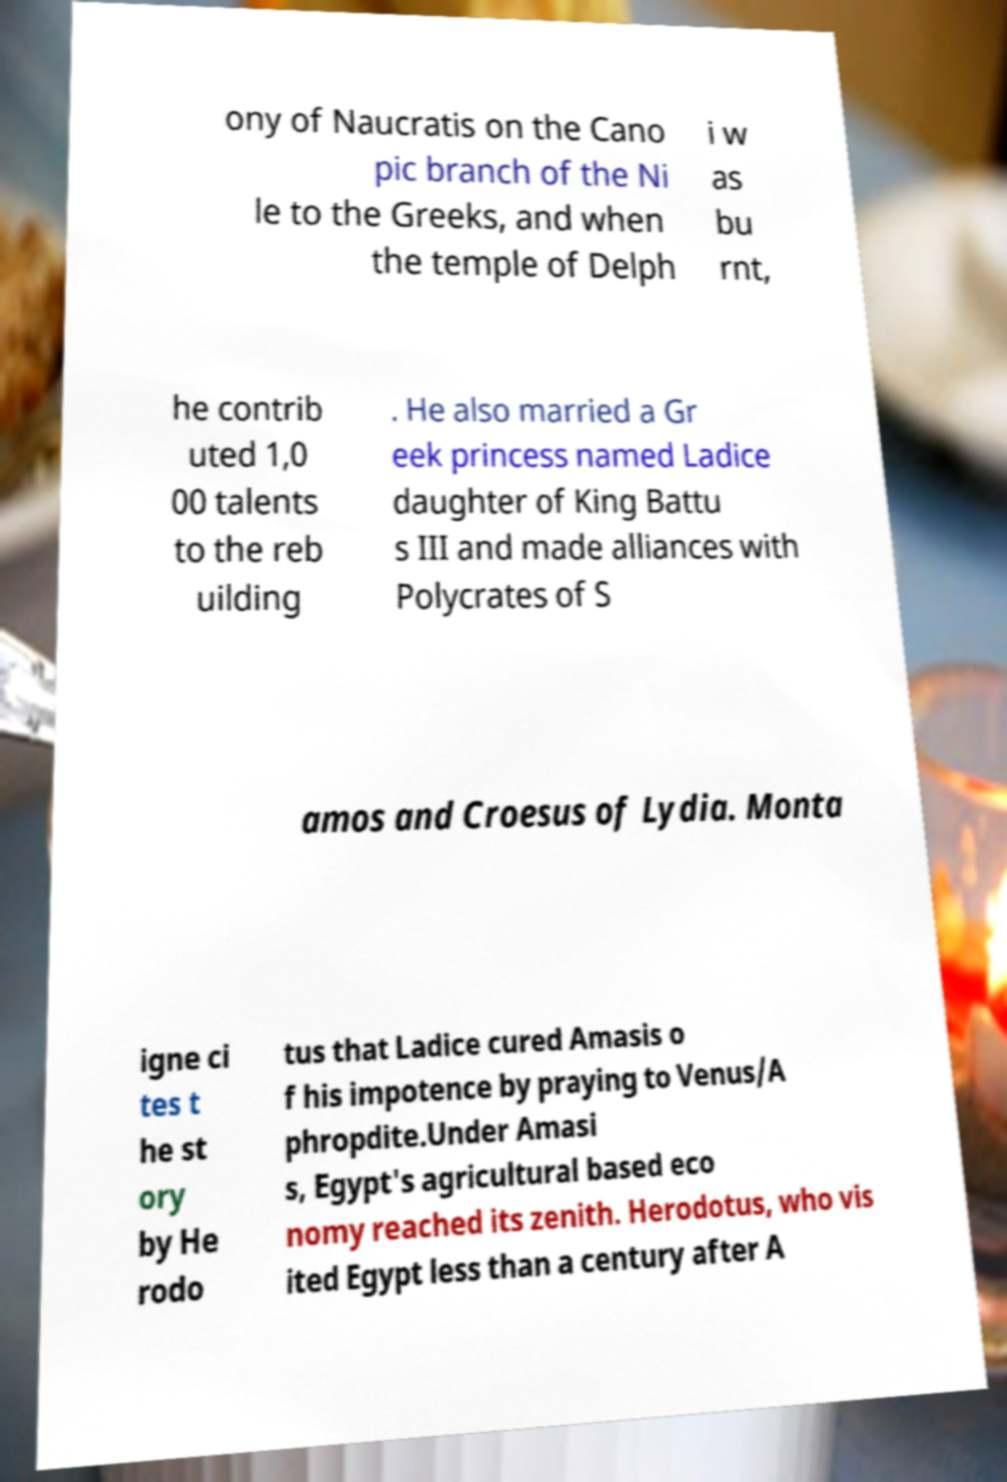There's text embedded in this image that I need extracted. Can you transcribe it verbatim? ony of Naucratis on the Cano pic branch of the Ni le to the Greeks, and when the temple of Delph i w as bu rnt, he contrib uted 1,0 00 talents to the reb uilding . He also married a Gr eek princess named Ladice daughter of King Battu s III and made alliances with Polycrates of S amos and Croesus of Lydia. Monta igne ci tes t he st ory by He rodo tus that Ladice cured Amasis o f his impotence by praying to Venus/A phropdite.Under Amasi s, Egypt's agricultural based eco nomy reached its zenith. Herodotus, who vis ited Egypt less than a century after A 